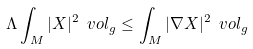Convert formula to latex. <formula><loc_0><loc_0><loc_500><loc_500>\Lambda \int _ { M } | X | ^ { 2 } \ v o l _ { g } \leq \int _ { M } | \nabla X | ^ { 2 } \ v o l _ { g }</formula> 